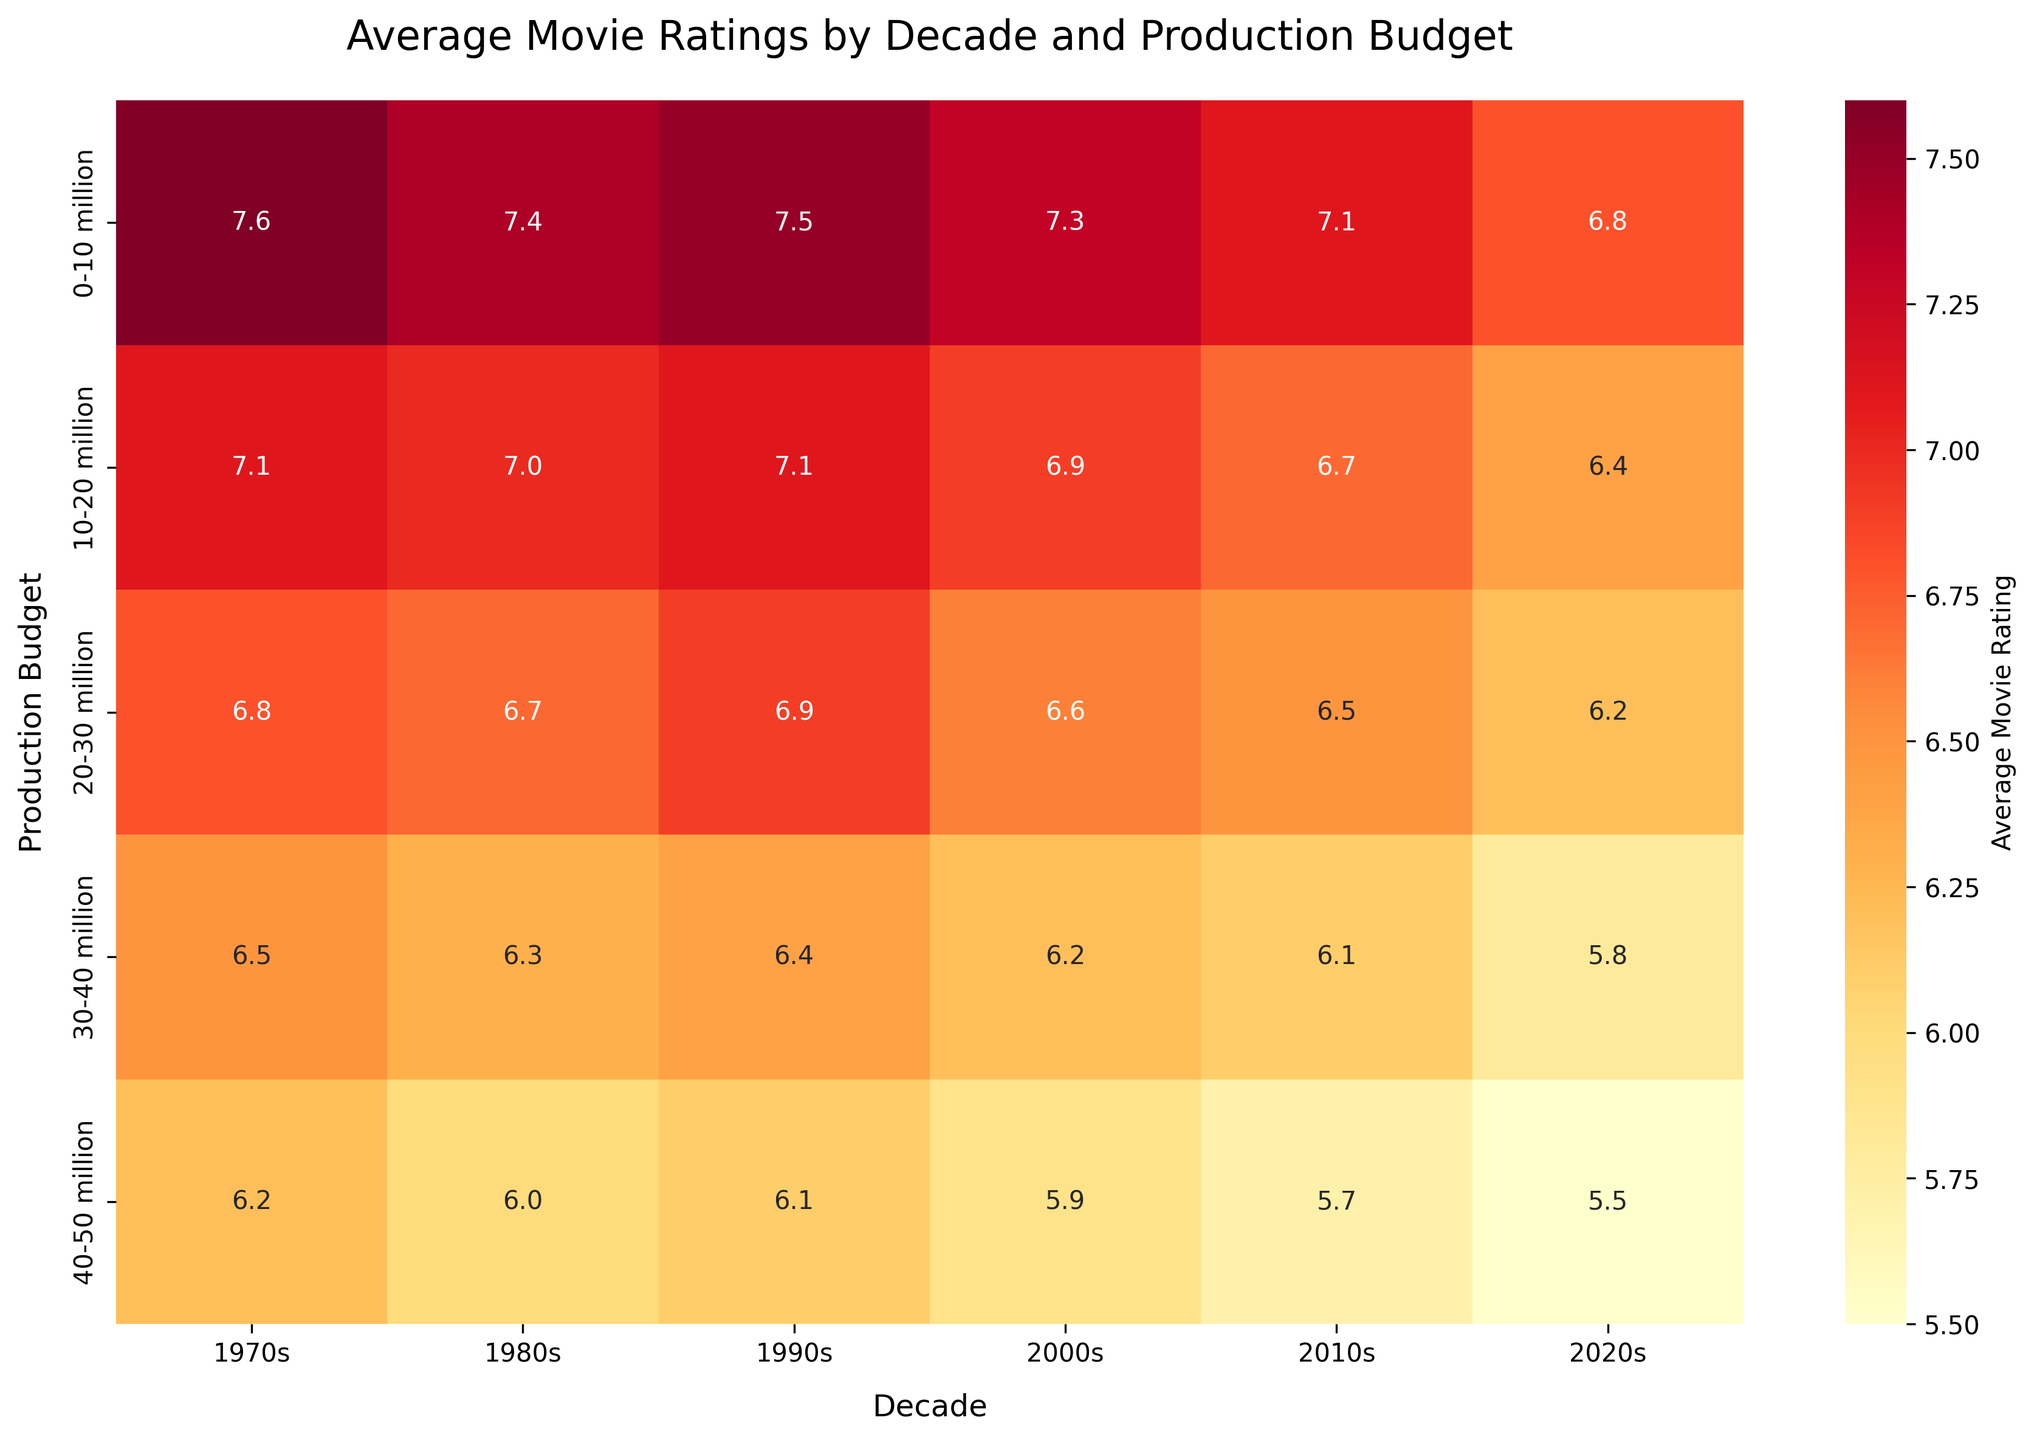What is the title of the heatmap? The title is written above the heatmap in large, bold font. This provides the main context of the data being visualized.
Answer: Average Movie Ratings by Decade and Production Budget Which decade had the highest average movie rating for films with a production budget of 0-10 million? Looking at the heatmap, locate the row for the '0-10 million' production budget and find the highest value within that row.
Answer: 1970s How does the average movie rating change with increasing production budget in the 1980s? Look vertically down the column for the '1980s'. Observe the trend of values as the production budget increases from '0-10 million' to '40-50 million'.
Answer: It decreases What was the average movie rating for movies produced in the 2000s with a budget of 20-30 million? Find the intersection of the '2000s' column and the '20-30 million' row in the heatmap.
Answer: 6.6 Which decade experienced the largest drop in average ratings when comparing movies with a budget of 0-10 million to those with a budget of 40-50 million? Calculate the difference in ratings between the '0-10 million' and '40-50 million' budgets for each decade, then identify the decade with the largest difference.
Answer: 2020s In which production budget range did the 1970s have its lowest average movie rating? Find the minimum value within the '1970s' column and note the corresponding production budget range.
Answer: 40-50 million Compare the average movie rating for a 10-20 million budget in the 1990s with a 30-40 million budget in the 2010s. Which is higher? Find the values at the intersections of '10-20 million' and '1990s', and '30-40 million' and '2010s'. Compare these values.
Answer: 1990s Is the average movie rating for films produced in the 2020s uniformly higher or lower across all budget ranges compared to the 1970s? Visually compare each production budget row for the '1970s' and '2020s' columns to determine if one is consistently higher or lower.
Answer: Lower What trend can be observed in the average movie ratings as the decades progress from the 1970s to the 2020s for the budget range of 10-20 million? Follow the '10-20 million' row from left to right across each column representing a decade, and note the trend in average movie ratings.
Answer: They generally decrease In which decade do films with a budget of 30-40 million have the highest average movie rating? Look at the '30-40 million' row and identify the highest value, then note the corresponding decade.
Answer: 1970s 